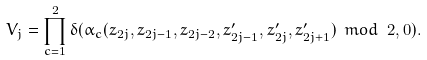<formula> <loc_0><loc_0><loc_500><loc_500>V _ { j } = \prod _ { c = 1 } ^ { 2 } \delta ( \alpha _ { c } ( z _ { 2 j } , z _ { 2 j - 1 } , z _ { 2 j - 2 } , z ^ { \prime } _ { 2 j - 1 } , z ^ { \prime } _ { 2 j } , z ^ { \prime } _ { 2 j + 1 } ) \ m o d \ 2 , 0 ) .</formula> 